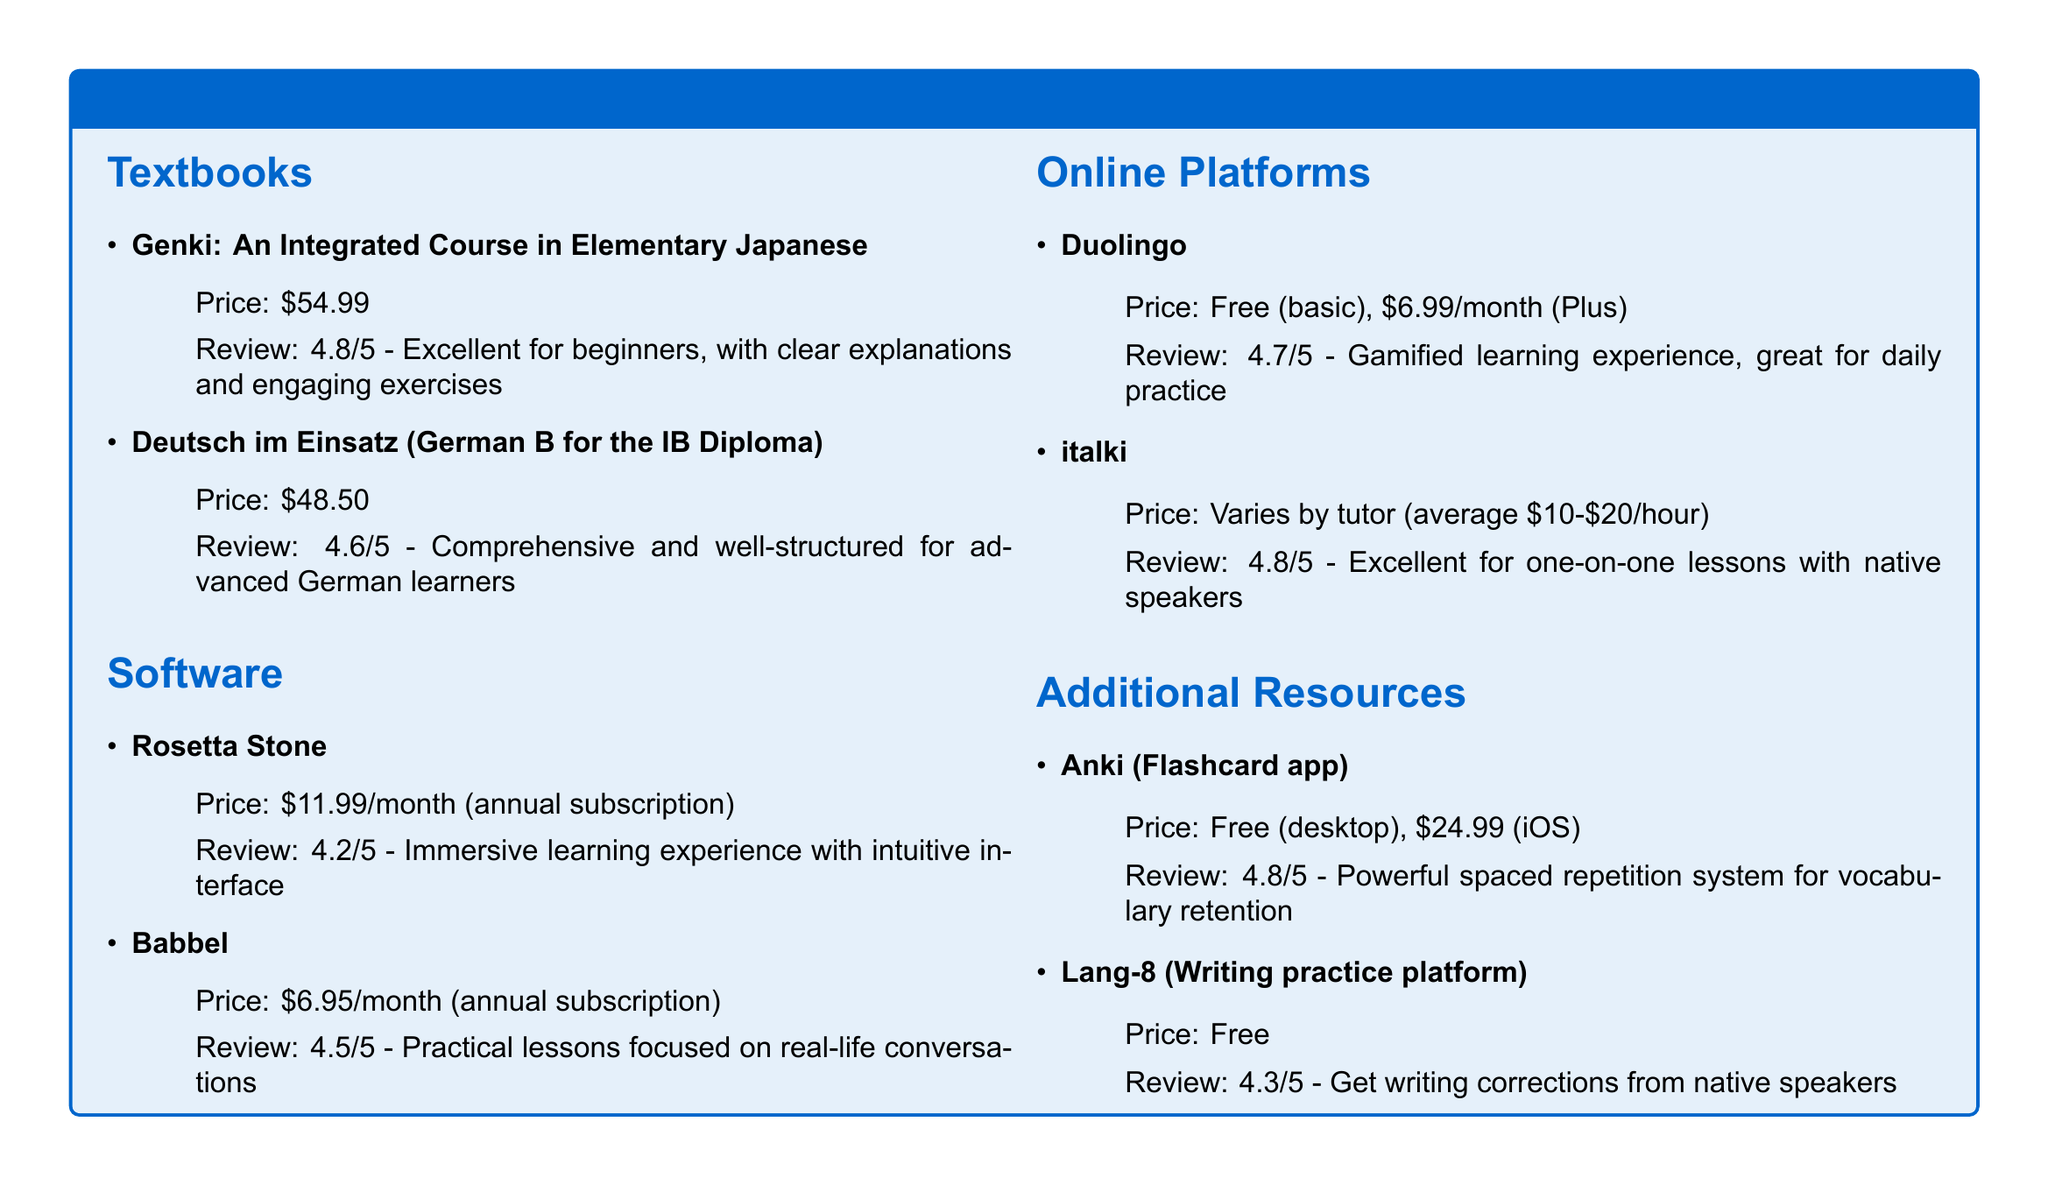What is the price of Genki? The price of Genki is listed in the document as $54.99.
Answer: $54.99 What is the review score for Rosetta Stone? The review score for Rosetta Stone is given as 4.2/5 in the document.
Answer: 4.2/5 Which textbook is recommended for advanced German learners? The document specifies "Deutsch im Einsatz (German B for the IB Diploma)" as the textbook for advanced German learners.
Answer: Deutsch im Einsatz (German B for the IB Diploma) What is the price range for tutoring on italki? The document states that the price varies by tutor, and the average is $10-$20/hour.
Answer: $10-$20/hour Which resource provides a powerful spaced repetition system? Anki is mentioned in the document as a resource providing a powerful spaced repetition system for vocabulary retention.
Answer: Anki Which software offers practical lessons focused on real-life conversations? The document states that Babbel offers practical lessons focused on real-life conversations.
Answer: Babbel What is the cost of the Plus version of Duolingo? The Plus version of Duolingo is priced at $6.99/month according to the document.
Answer: $6.99/month How high is the review score for Lang-8? According to the document, Lang-8 has a review score of 4.3/5.
Answer: 4.3/5 What type of platform is Anki described as? The document describes Anki as a flashcard app.
Answer: Flashcard app 